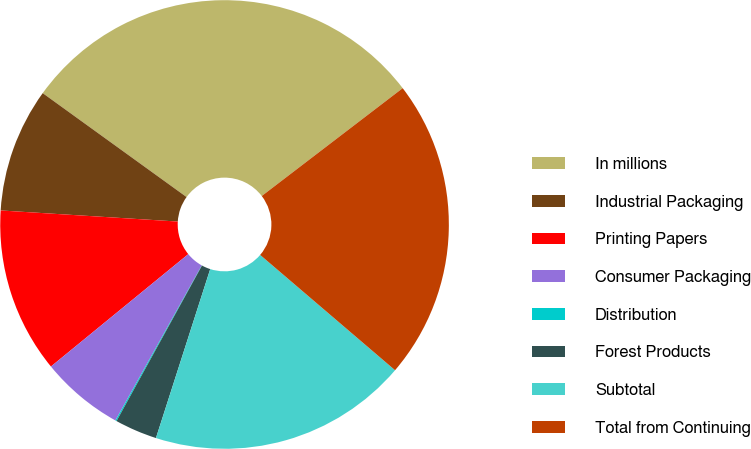Convert chart. <chart><loc_0><loc_0><loc_500><loc_500><pie_chart><fcel>In millions<fcel>Industrial Packaging<fcel>Printing Papers<fcel>Consumer Packaging<fcel>Distribution<fcel>Forest Products<fcel>Subtotal<fcel>Total from Continuing<nl><fcel>29.65%<fcel>8.96%<fcel>11.91%<fcel>6.0%<fcel>0.09%<fcel>3.05%<fcel>18.69%<fcel>21.65%<nl></chart> 